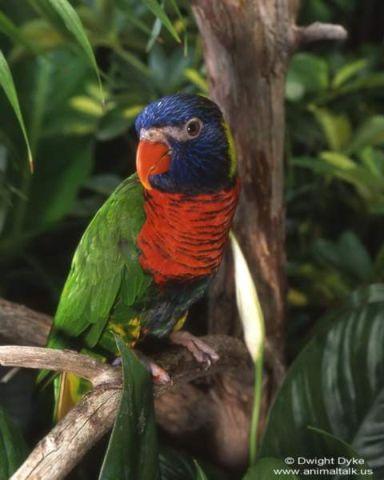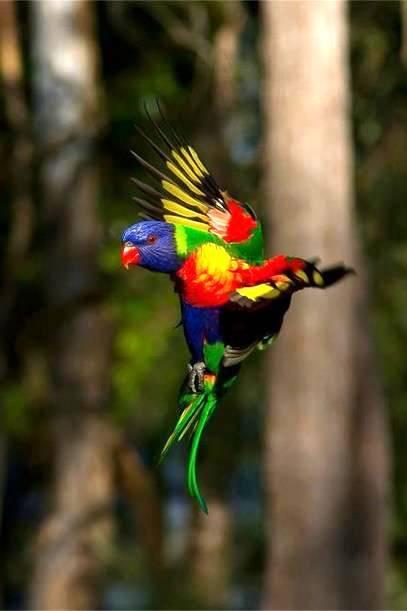The first image is the image on the left, the second image is the image on the right. For the images shown, is this caption "There are no more than three birds" true? Answer yes or no. Yes. The first image is the image on the left, the second image is the image on the right. Given the left and right images, does the statement "In total, the images contain no more than three parrots." hold true? Answer yes or no. Yes. 